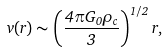Convert formula to latex. <formula><loc_0><loc_0><loc_500><loc_500>v ( r ) \sim \left ( \frac { 4 \pi G _ { 0 } \rho _ { c } } { 3 } \right ) ^ { 1 / 2 } r ,</formula> 